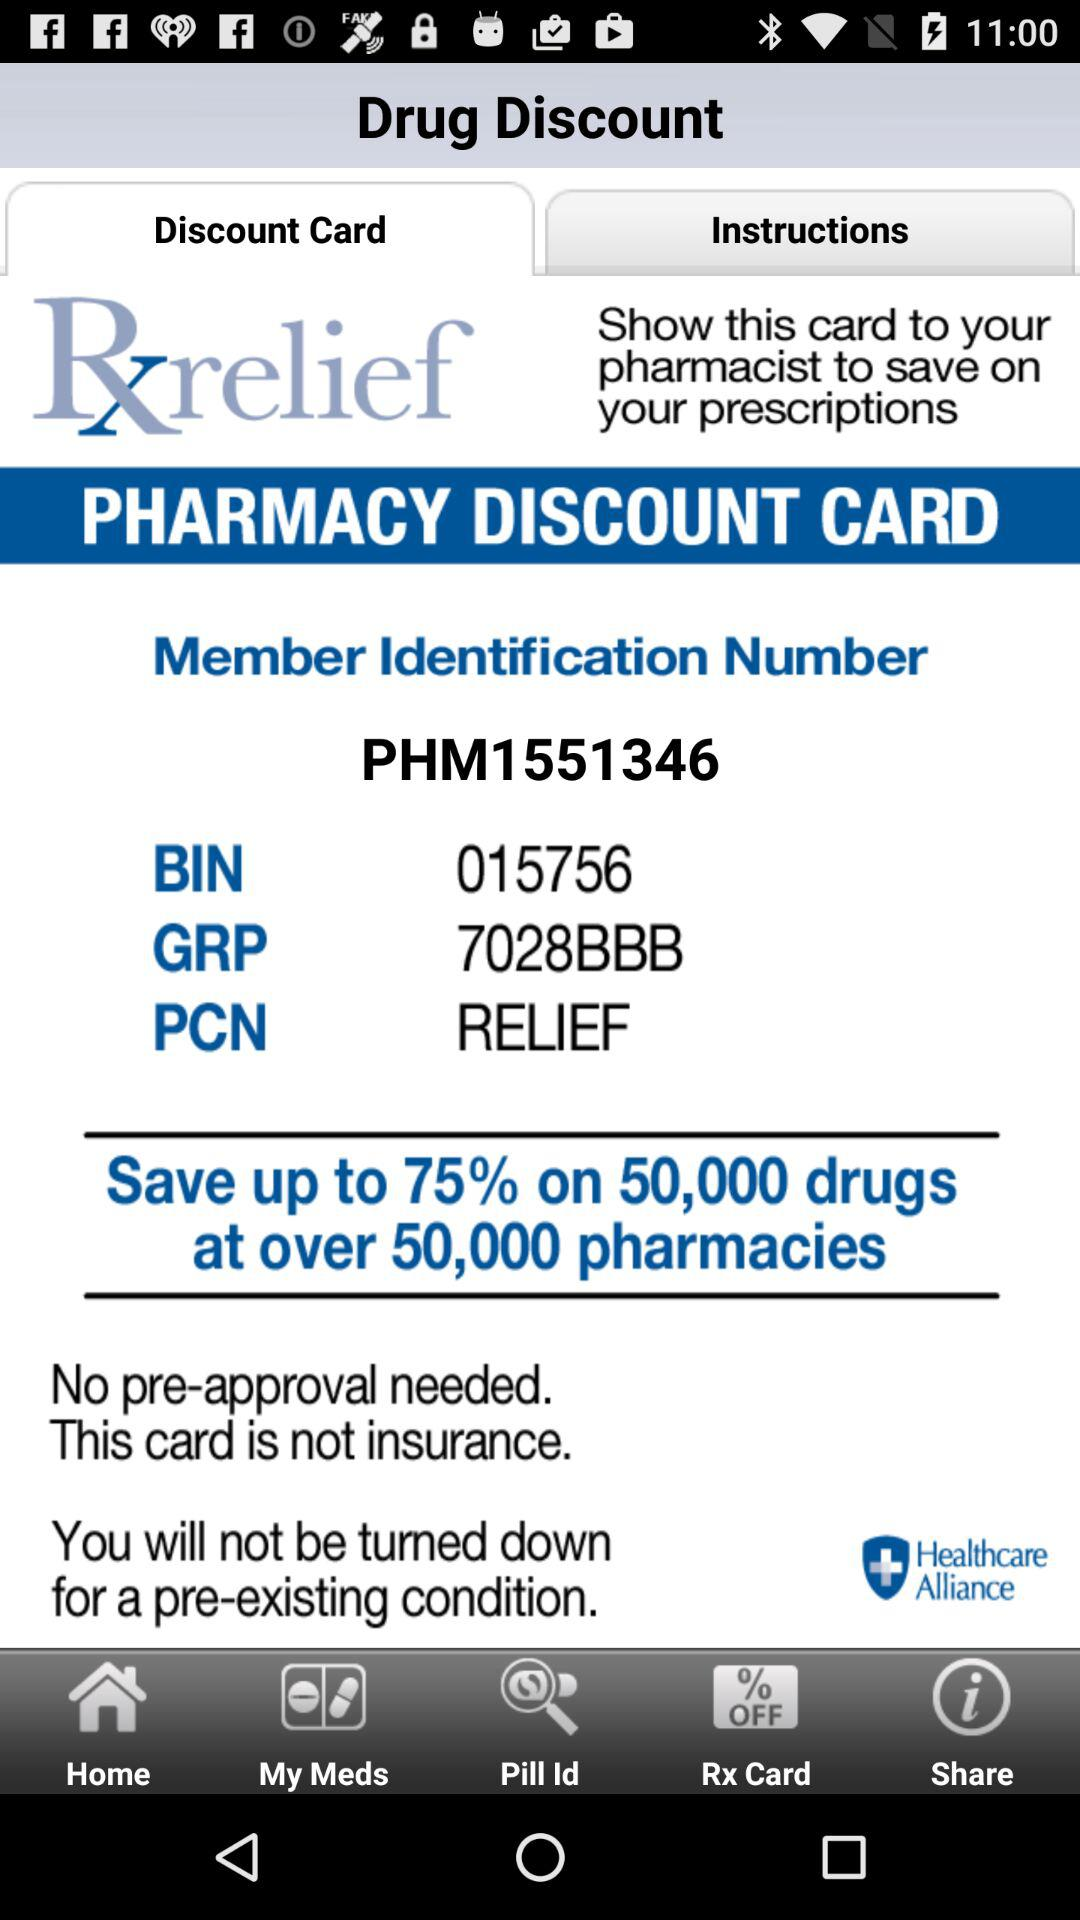What is the application name? The application name is "Drug Discount". 